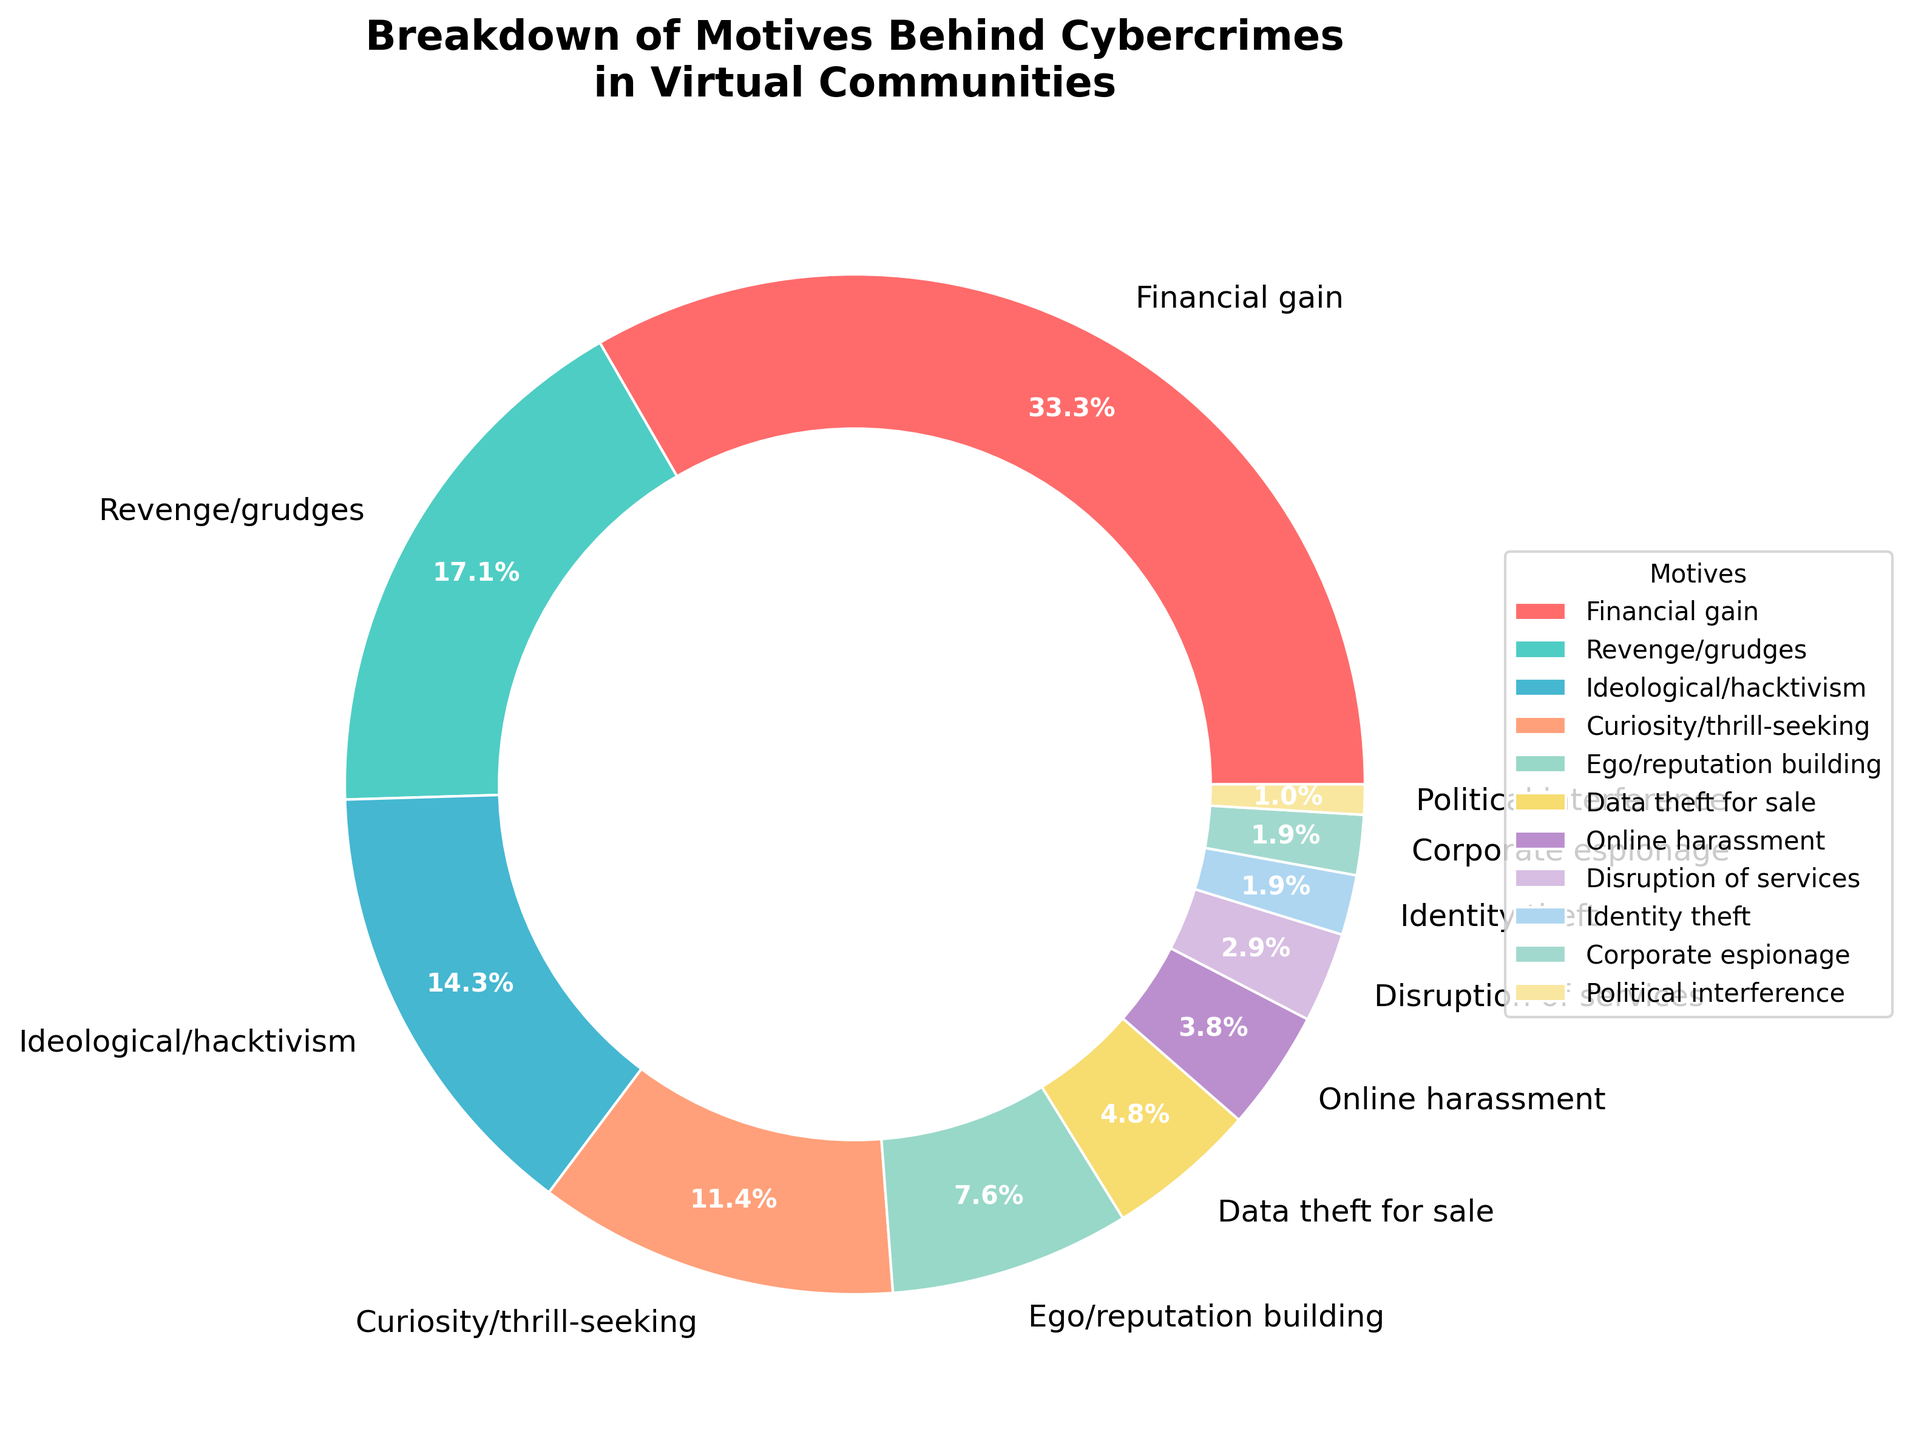What is the most common motive behind cybercrimes in virtual communities? The pie chart shows that the largest segment corresponds to Financial gain with a percentage of 35%, making it the most common motive.
Answer: Financial gain Which motive has a higher percentage, Curiosity/thrill-seeking or Ego/reputation building? Curiosity/thrill-seeking has a percentage of 12% while Ego/reputation building has a percentage of 8%. Since 12% is greater than 8%, Curiosity/thrill-seeking has a higher percentage.
Answer: Curiosity/thrill-seeking What is the combined percentage of Revenge/grudges and Ideological/hacktivism? The percentage for Revenge/grudges is 18% and for Ideological/hacktivism is 15%. The combined percentage is 18% + 15% = 33%.
Answer: 33% Which color represents the motive associated with technological curiosity or thrill-seeking? The section representing Curiosity/thrill-seeking is shown in a yellowish color on the pie chart.
Answer: Yellow What is the total percentage contribution of the least common motives (each below 5%)? The least common motives and their percentages are: Online harassment (4%), Disruption of services (3%), Identity theft (2%), Corporate espionage (2%), and Political interference (1%). Adding these up: 4% + 3% + 2% + 2% + 1% = 12%.
Answer: 12% How does the percentage of Data theft for sale compare with Online harassment? Data theft for sale has a percentage of 5% and Online harassment has a percentage of 4%. Since 5% is greater than 4%, Data theft for sale has a higher percentage than Online harassment.
Answer: Data theft for sale Which motive is depicted by the smallest segment in the pie chart and what is its percentage? The smallest segment in the pie chart represents Political interference with a percentage of 1%.
Answer: Political interference, 1% If we group Financial gain and Data theft for sale motives, what is their combined percentage? Financial gain has a percentage of 35% and Data theft for sale has 5%. Their combined percentage is 35% + 5% = 40%.
Answer: 40% Which motive occupies more than one-third of the pie chart? By examining the pie chart, the segment occupying more than one-third (approximately 33.3%) of the pie chart is Financial gain with 35%.
Answer: Financial gain What is the difference in percentage between Revenge/grudges and Identity theft? The percentage for Revenge/grudges is 18% and for Identity theft is 2%. The difference is 18% - 2% = 16%.
Answer: 16% 